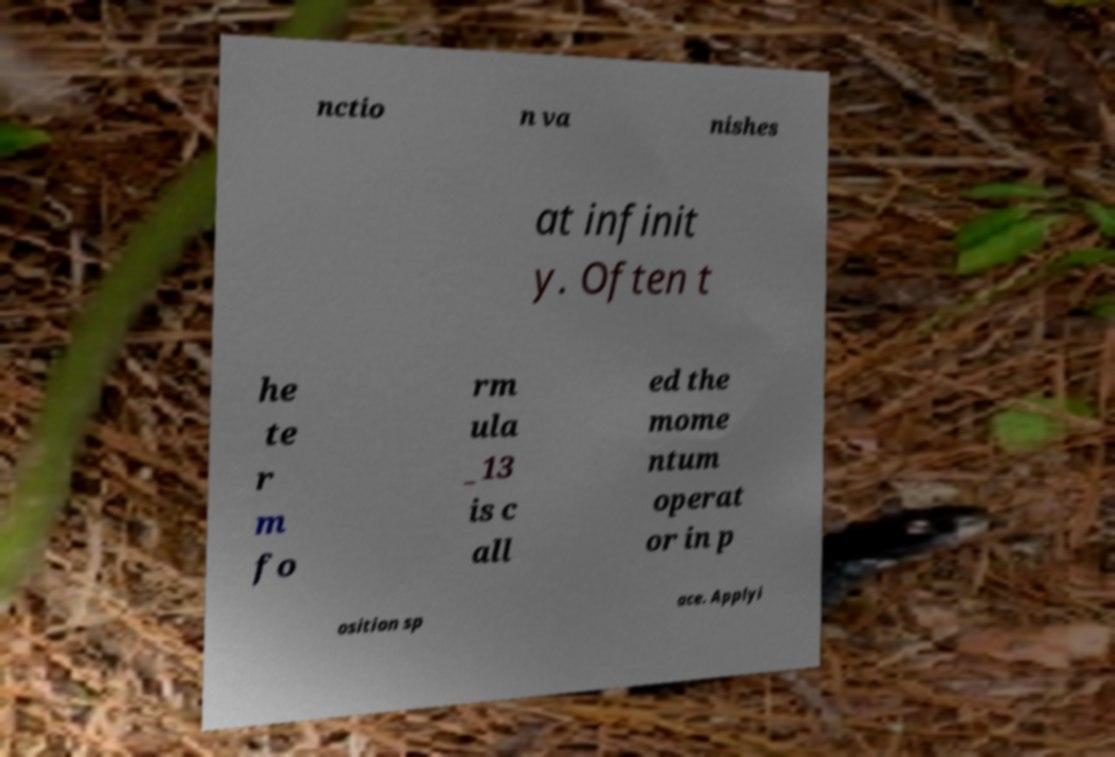There's text embedded in this image that I need extracted. Can you transcribe it verbatim? nctio n va nishes at infinit y. Often t he te r m fo rm ula _13 is c all ed the mome ntum operat or in p osition sp ace. Applyi 